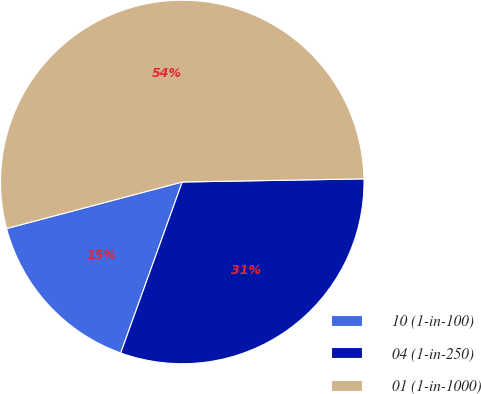Convert chart. <chart><loc_0><loc_0><loc_500><loc_500><pie_chart><fcel>10 (1-in-100)<fcel>04 (1-in-250)<fcel>01 (1-in-1000)<nl><fcel>15.38%<fcel>30.77%<fcel>53.85%<nl></chart> 